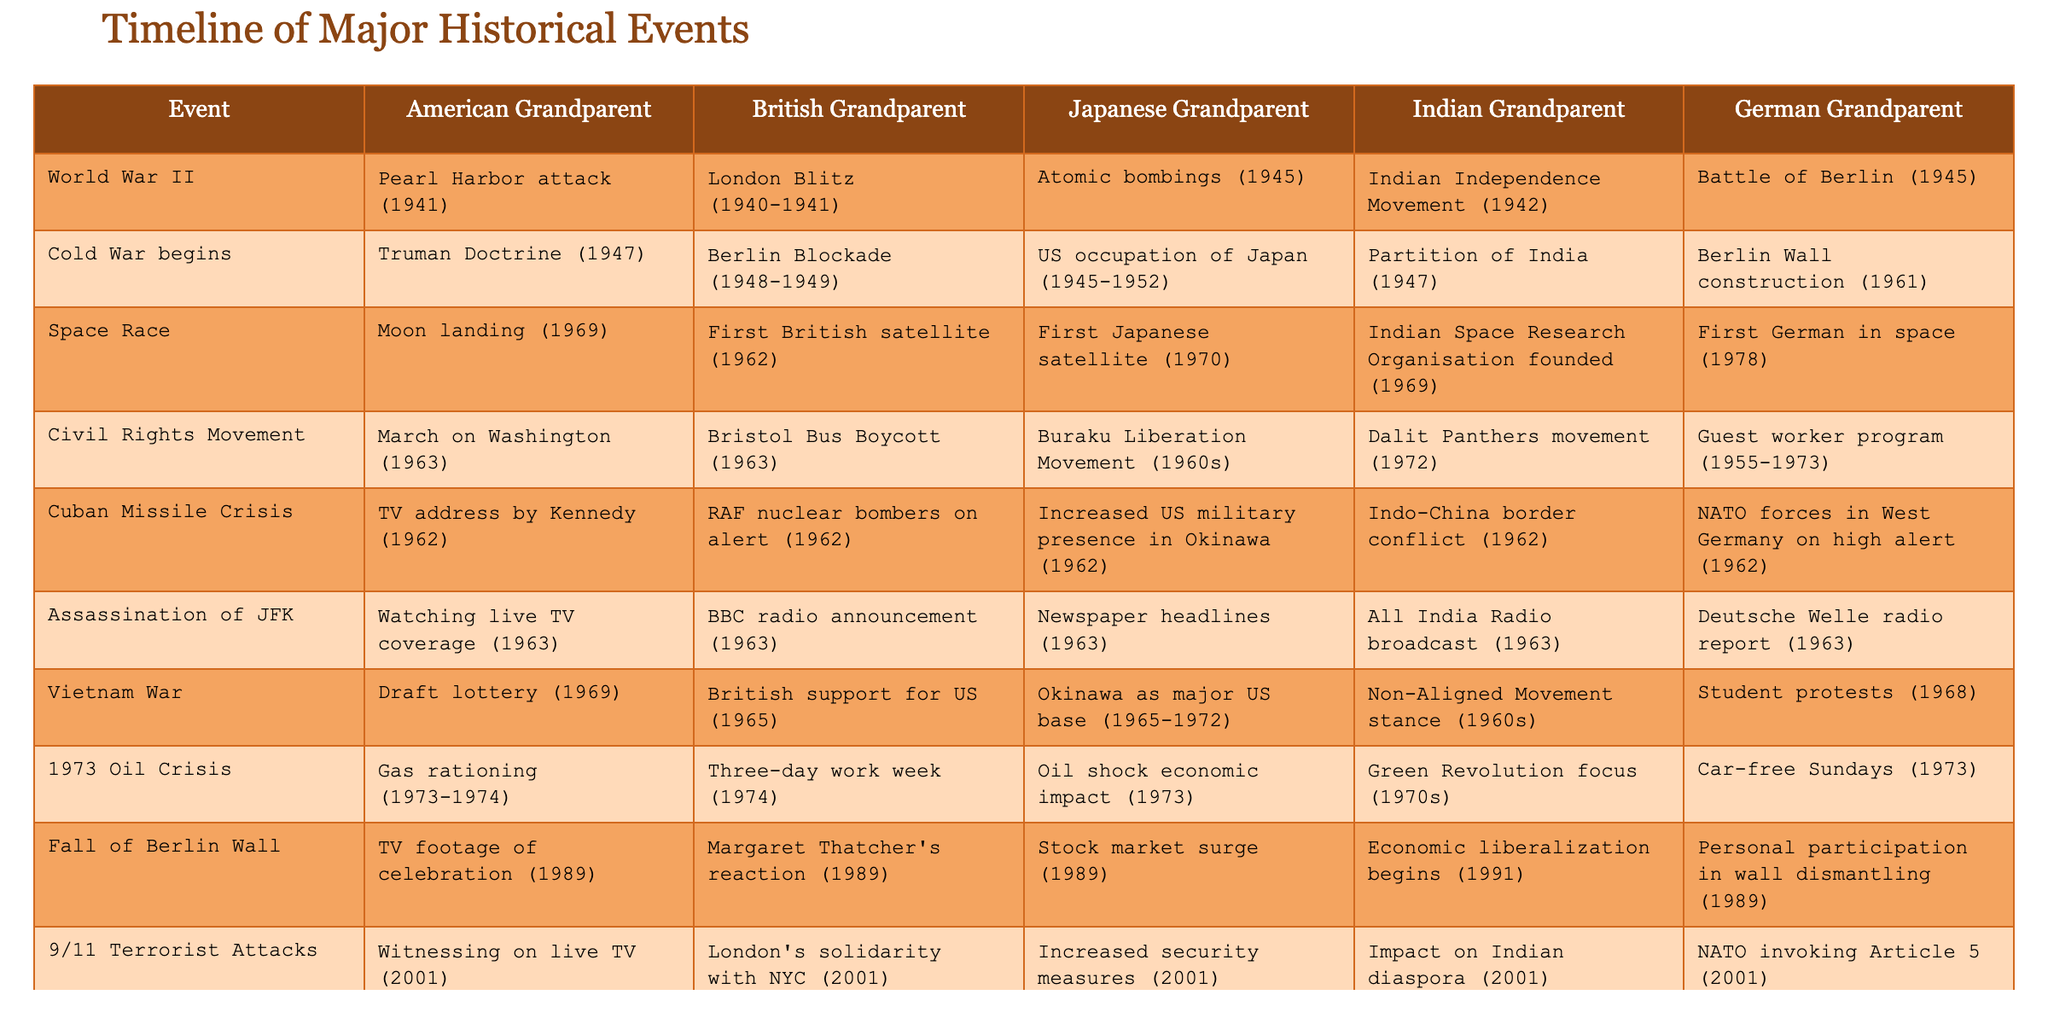What event is recalled by the Indian grandparent during World War II? In the provided table, the event recalled by the Indian grandparent under World War II is the Indian Independence Movement (1942).
Answer: Indian Independence Movement (1942) Which grandparent recalls an event related to the Cold War starting? The American grandparent recalls the Truman Doctrine (1947) as an event related to the start of the Cold War.
Answer: Truman Doctrine (1947) Did the British grandparent note an event related to the Civil Rights Movement? Yes, the British grandparent noted the Bristol Bus Boycott (1963) as an event related to the Civil Rights Movement.
Answer: Yes What major event occurred in 1989 according to the American grandparent? The major event that occurred in 1989, as recalled by the American grandparent, is the TV footage of the celebration of the Fall of Berlin Wall.
Answer: TV footage of celebration (1989) Which event associated with the Vietnam War is noted by the Japanese grandparent? The Japanese grandparent noted that Okinawa served as a major US base during the Vietnam War (1965-1972).
Answer: Okinawa as major US base (1965-1972) Which grandparent recalls a response to the 9/11 terrorist attacks? The American grandparent recalls witnessing the 9/11 terrorist attacks on live TV.
Answer: Witnessing on live TV (2001) How many major events did the Indian grandparent recall from the timeline? The Indian grandparent recalled five major events from the timeline (one per each historical period listed).
Answer: 5 Which event was shared by both the American and Indian grandparents in 1963? Both the American and Indian grandparents recall significant events in 1963; the American grandparent mentions watching live TV coverage of JFK's assassination, while the Indian grandparent noted the All India Radio broadcast of the same event.
Answer: JFK assassination coverage What was the response from the British grandparent during the Cuban Missile Crisis? The British grandparent noted RAF nuclear bombers being on alert in 1962 during the Cuban Missile Crisis.
Answer: RAF nuclear bombers on alert (1962) List the events associated with the Space Race mentioned by each grandparent. The American grandparent noted the Moon landing (1969), the British grandparent recalled the First British satellite (1962), the Japanese grandparent mentioned the First Japanese satellite (1970), the Indian grandparent mentioned the founding of the Indian Space Research Organisation (1969), and the German grandparent noted the First German in space (1978).
Answer: Various Space Race Events What can be inferred about the historical perspectives of the grandparents from their events recalled? The events recalled by the grandparents reflect their national experiences, shaping their understanding of significant world events. Each grandparent's account emphasizes the unique circumstances faced by their countries during the highlighted historical moments.
Answer: National perspectives vary 